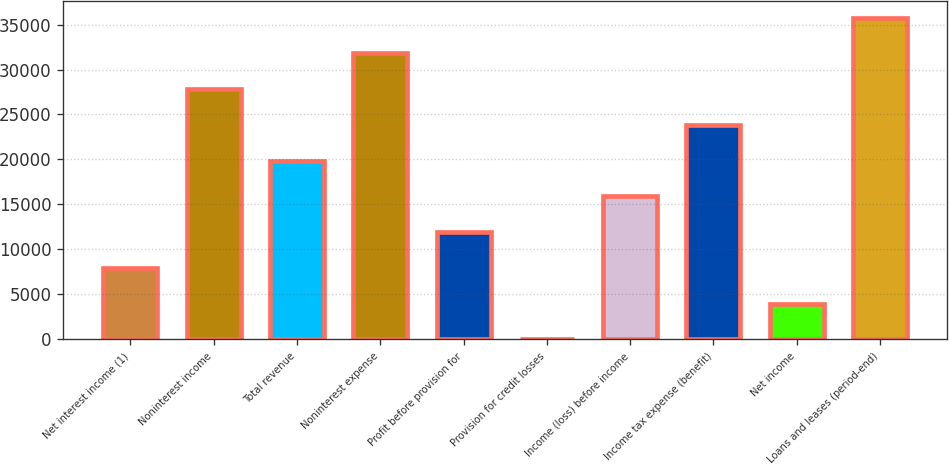Convert chart. <chart><loc_0><loc_0><loc_500><loc_500><bar_chart><fcel>Net interest income (1)<fcel>Noninterest income<fcel>Total revenue<fcel>Noninterest expense<fcel>Profit before provision for<fcel>Provision for credit losses<fcel>Income (loss) before income<fcel>Income tax expense (benefit)<fcel>Net income<fcel>Loans and leases (period-end)<nl><fcel>7958.2<fcel>27826.2<fcel>19879<fcel>31799.8<fcel>11931.8<fcel>11<fcel>15905.4<fcel>23852.6<fcel>3984.6<fcel>35773.4<nl></chart> 